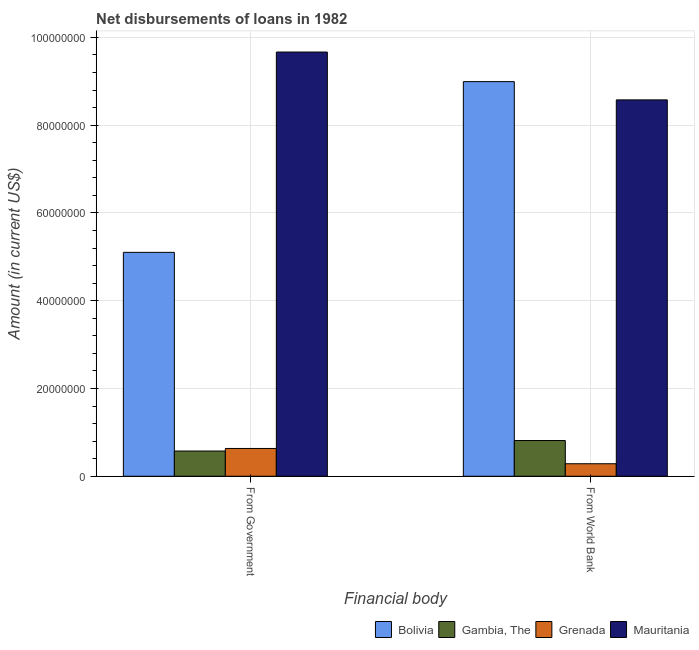How many groups of bars are there?
Provide a short and direct response. 2. Are the number of bars per tick equal to the number of legend labels?
Offer a terse response. Yes. How many bars are there on the 2nd tick from the right?
Give a very brief answer. 4. What is the label of the 2nd group of bars from the left?
Offer a terse response. From World Bank. What is the net disbursements of loan from world bank in Bolivia?
Your answer should be compact. 8.99e+07. Across all countries, what is the maximum net disbursements of loan from world bank?
Your answer should be very brief. 8.99e+07. Across all countries, what is the minimum net disbursements of loan from world bank?
Ensure brevity in your answer.  2.85e+06. In which country was the net disbursements of loan from government maximum?
Ensure brevity in your answer.  Mauritania. In which country was the net disbursements of loan from world bank minimum?
Provide a short and direct response. Grenada. What is the total net disbursements of loan from world bank in the graph?
Provide a short and direct response. 1.87e+08. What is the difference between the net disbursements of loan from world bank in Grenada and that in Mauritania?
Offer a terse response. -8.29e+07. What is the difference between the net disbursements of loan from world bank in Grenada and the net disbursements of loan from government in Mauritania?
Offer a terse response. -9.38e+07. What is the average net disbursements of loan from government per country?
Provide a short and direct response. 3.99e+07. What is the difference between the net disbursements of loan from government and net disbursements of loan from world bank in Bolivia?
Provide a short and direct response. -3.89e+07. In how many countries, is the net disbursements of loan from government greater than 20000000 US$?
Keep it short and to the point. 2. What is the ratio of the net disbursements of loan from government in Bolivia to that in Mauritania?
Your answer should be compact. 0.53. Is the net disbursements of loan from government in Bolivia less than that in Mauritania?
Provide a short and direct response. Yes. In how many countries, is the net disbursements of loan from government greater than the average net disbursements of loan from government taken over all countries?
Offer a terse response. 2. What does the 2nd bar from the left in From World Bank represents?
Your answer should be very brief. Gambia, The. What does the 4th bar from the right in From Government represents?
Provide a short and direct response. Bolivia. How many bars are there?
Your response must be concise. 8. What is the difference between two consecutive major ticks on the Y-axis?
Provide a short and direct response. 2.00e+07. Are the values on the major ticks of Y-axis written in scientific E-notation?
Your answer should be very brief. No. Does the graph contain grids?
Make the answer very short. Yes. How many legend labels are there?
Your answer should be compact. 4. How are the legend labels stacked?
Offer a terse response. Horizontal. What is the title of the graph?
Give a very brief answer. Net disbursements of loans in 1982. Does "Solomon Islands" appear as one of the legend labels in the graph?
Make the answer very short. No. What is the label or title of the X-axis?
Your answer should be compact. Financial body. What is the Amount (in current US$) in Bolivia in From Government?
Give a very brief answer. 5.10e+07. What is the Amount (in current US$) in Gambia, The in From Government?
Your response must be concise. 5.75e+06. What is the Amount (in current US$) of Grenada in From Government?
Offer a very short reply. 6.33e+06. What is the Amount (in current US$) of Mauritania in From Government?
Keep it short and to the point. 9.67e+07. What is the Amount (in current US$) of Bolivia in From World Bank?
Offer a very short reply. 8.99e+07. What is the Amount (in current US$) in Gambia, The in From World Bank?
Your answer should be very brief. 8.14e+06. What is the Amount (in current US$) in Grenada in From World Bank?
Make the answer very short. 2.85e+06. What is the Amount (in current US$) of Mauritania in From World Bank?
Your answer should be very brief. 8.58e+07. Across all Financial body, what is the maximum Amount (in current US$) of Bolivia?
Keep it short and to the point. 8.99e+07. Across all Financial body, what is the maximum Amount (in current US$) in Gambia, The?
Provide a succinct answer. 8.14e+06. Across all Financial body, what is the maximum Amount (in current US$) of Grenada?
Make the answer very short. 6.33e+06. Across all Financial body, what is the maximum Amount (in current US$) of Mauritania?
Give a very brief answer. 9.67e+07. Across all Financial body, what is the minimum Amount (in current US$) of Bolivia?
Your answer should be compact. 5.10e+07. Across all Financial body, what is the minimum Amount (in current US$) of Gambia, The?
Ensure brevity in your answer.  5.75e+06. Across all Financial body, what is the minimum Amount (in current US$) in Grenada?
Make the answer very short. 2.85e+06. Across all Financial body, what is the minimum Amount (in current US$) in Mauritania?
Keep it short and to the point. 8.58e+07. What is the total Amount (in current US$) of Bolivia in the graph?
Your answer should be very brief. 1.41e+08. What is the total Amount (in current US$) in Gambia, The in the graph?
Your response must be concise. 1.39e+07. What is the total Amount (in current US$) in Grenada in the graph?
Your answer should be compact. 9.18e+06. What is the total Amount (in current US$) in Mauritania in the graph?
Keep it short and to the point. 1.82e+08. What is the difference between the Amount (in current US$) of Bolivia in From Government and that in From World Bank?
Your response must be concise. -3.89e+07. What is the difference between the Amount (in current US$) of Gambia, The in From Government and that in From World Bank?
Ensure brevity in your answer.  -2.39e+06. What is the difference between the Amount (in current US$) of Grenada in From Government and that in From World Bank?
Offer a very short reply. 3.48e+06. What is the difference between the Amount (in current US$) of Mauritania in From Government and that in From World Bank?
Your answer should be compact. 1.09e+07. What is the difference between the Amount (in current US$) of Bolivia in From Government and the Amount (in current US$) of Gambia, The in From World Bank?
Your answer should be compact. 4.29e+07. What is the difference between the Amount (in current US$) of Bolivia in From Government and the Amount (in current US$) of Grenada in From World Bank?
Give a very brief answer. 4.82e+07. What is the difference between the Amount (in current US$) of Bolivia in From Government and the Amount (in current US$) of Mauritania in From World Bank?
Offer a very short reply. -3.47e+07. What is the difference between the Amount (in current US$) of Gambia, The in From Government and the Amount (in current US$) of Grenada in From World Bank?
Your answer should be compact. 2.90e+06. What is the difference between the Amount (in current US$) of Gambia, The in From Government and the Amount (in current US$) of Mauritania in From World Bank?
Provide a succinct answer. -8.00e+07. What is the difference between the Amount (in current US$) in Grenada in From Government and the Amount (in current US$) in Mauritania in From World Bank?
Provide a succinct answer. -7.94e+07. What is the average Amount (in current US$) in Bolivia per Financial body?
Your answer should be very brief. 7.05e+07. What is the average Amount (in current US$) of Gambia, The per Financial body?
Keep it short and to the point. 6.94e+06. What is the average Amount (in current US$) in Grenada per Financial body?
Offer a terse response. 4.59e+06. What is the average Amount (in current US$) in Mauritania per Financial body?
Offer a terse response. 9.12e+07. What is the difference between the Amount (in current US$) in Bolivia and Amount (in current US$) in Gambia, The in From Government?
Provide a short and direct response. 4.53e+07. What is the difference between the Amount (in current US$) of Bolivia and Amount (in current US$) of Grenada in From Government?
Provide a short and direct response. 4.47e+07. What is the difference between the Amount (in current US$) in Bolivia and Amount (in current US$) in Mauritania in From Government?
Provide a short and direct response. -4.56e+07. What is the difference between the Amount (in current US$) in Gambia, The and Amount (in current US$) in Grenada in From Government?
Make the answer very short. -5.83e+05. What is the difference between the Amount (in current US$) in Gambia, The and Amount (in current US$) in Mauritania in From Government?
Offer a very short reply. -9.09e+07. What is the difference between the Amount (in current US$) of Grenada and Amount (in current US$) of Mauritania in From Government?
Keep it short and to the point. -9.03e+07. What is the difference between the Amount (in current US$) in Bolivia and Amount (in current US$) in Gambia, The in From World Bank?
Provide a succinct answer. 8.18e+07. What is the difference between the Amount (in current US$) of Bolivia and Amount (in current US$) of Grenada in From World Bank?
Give a very brief answer. 8.71e+07. What is the difference between the Amount (in current US$) of Bolivia and Amount (in current US$) of Mauritania in From World Bank?
Ensure brevity in your answer.  4.16e+06. What is the difference between the Amount (in current US$) in Gambia, The and Amount (in current US$) in Grenada in From World Bank?
Your answer should be very brief. 5.29e+06. What is the difference between the Amount (in current US$) in Gambia, The and Amount (in current US$) in Mauritania in From World Bank?
Provide a succinct answer. -7.76e+07. What is the difference between the Amount (in current US$) in Grenada and Amount (in current US$) in Mauritania in From World Bank?
Offer a very short reply. -8.29e+07. What is the ratio of the Amount (in current US$) of Bolivia in From Government to that in From World Bank?
Your answer should be very brief. 0.57. What is the ratio of the Amount (in current US$) in Gambia, The in From Government to that in From World Bank?
Your response must be concise. 0.71. What is the ratio of the Amount (in current US$) of Grenada in From Government to that in From World Bank?
Ensure brevity in your answer.  2.22. What is the ratio of the Amount (in current US$) in Mauritania in From Government to that in From World Bank?
Keep it short and to the point. 1.13. What is the difference between the highest and the second highest Amount (in current US$) of Bolivia?
Offer a very short reply. 3.89e+07. What is the difference between the highest and the second highest Amount (in current US$) of Gambia, The?
Offer a very short reply. 2.39e+06. What is the difference between the highest and the second highest Amount (in current US$) of Grenada?
Your answer should be very brief. 3.48e+06. What is the difference between the highest and the second highest Amount (in current US$) of Mauritania?
Your answer should be very brief. 1.09e+07. What is the difference between the highest and the lowest Amount (in current US$) in Bolivia?
Provide a succinct answer. 3.89e+07. What is the difference between the highest and the lowest Amount (in current US$) of Gambia, The?
Give a very brief answer. 2.39e+06. What is the difference between the highest and the lowest Amount (in current US$) in Grenada?
Give a very brief answer. 3.48e+06. What is the difference between the highest and the lowest Amount (in current US$) of Mauritania?
Keep it short and to the point. 1.09e+07. 